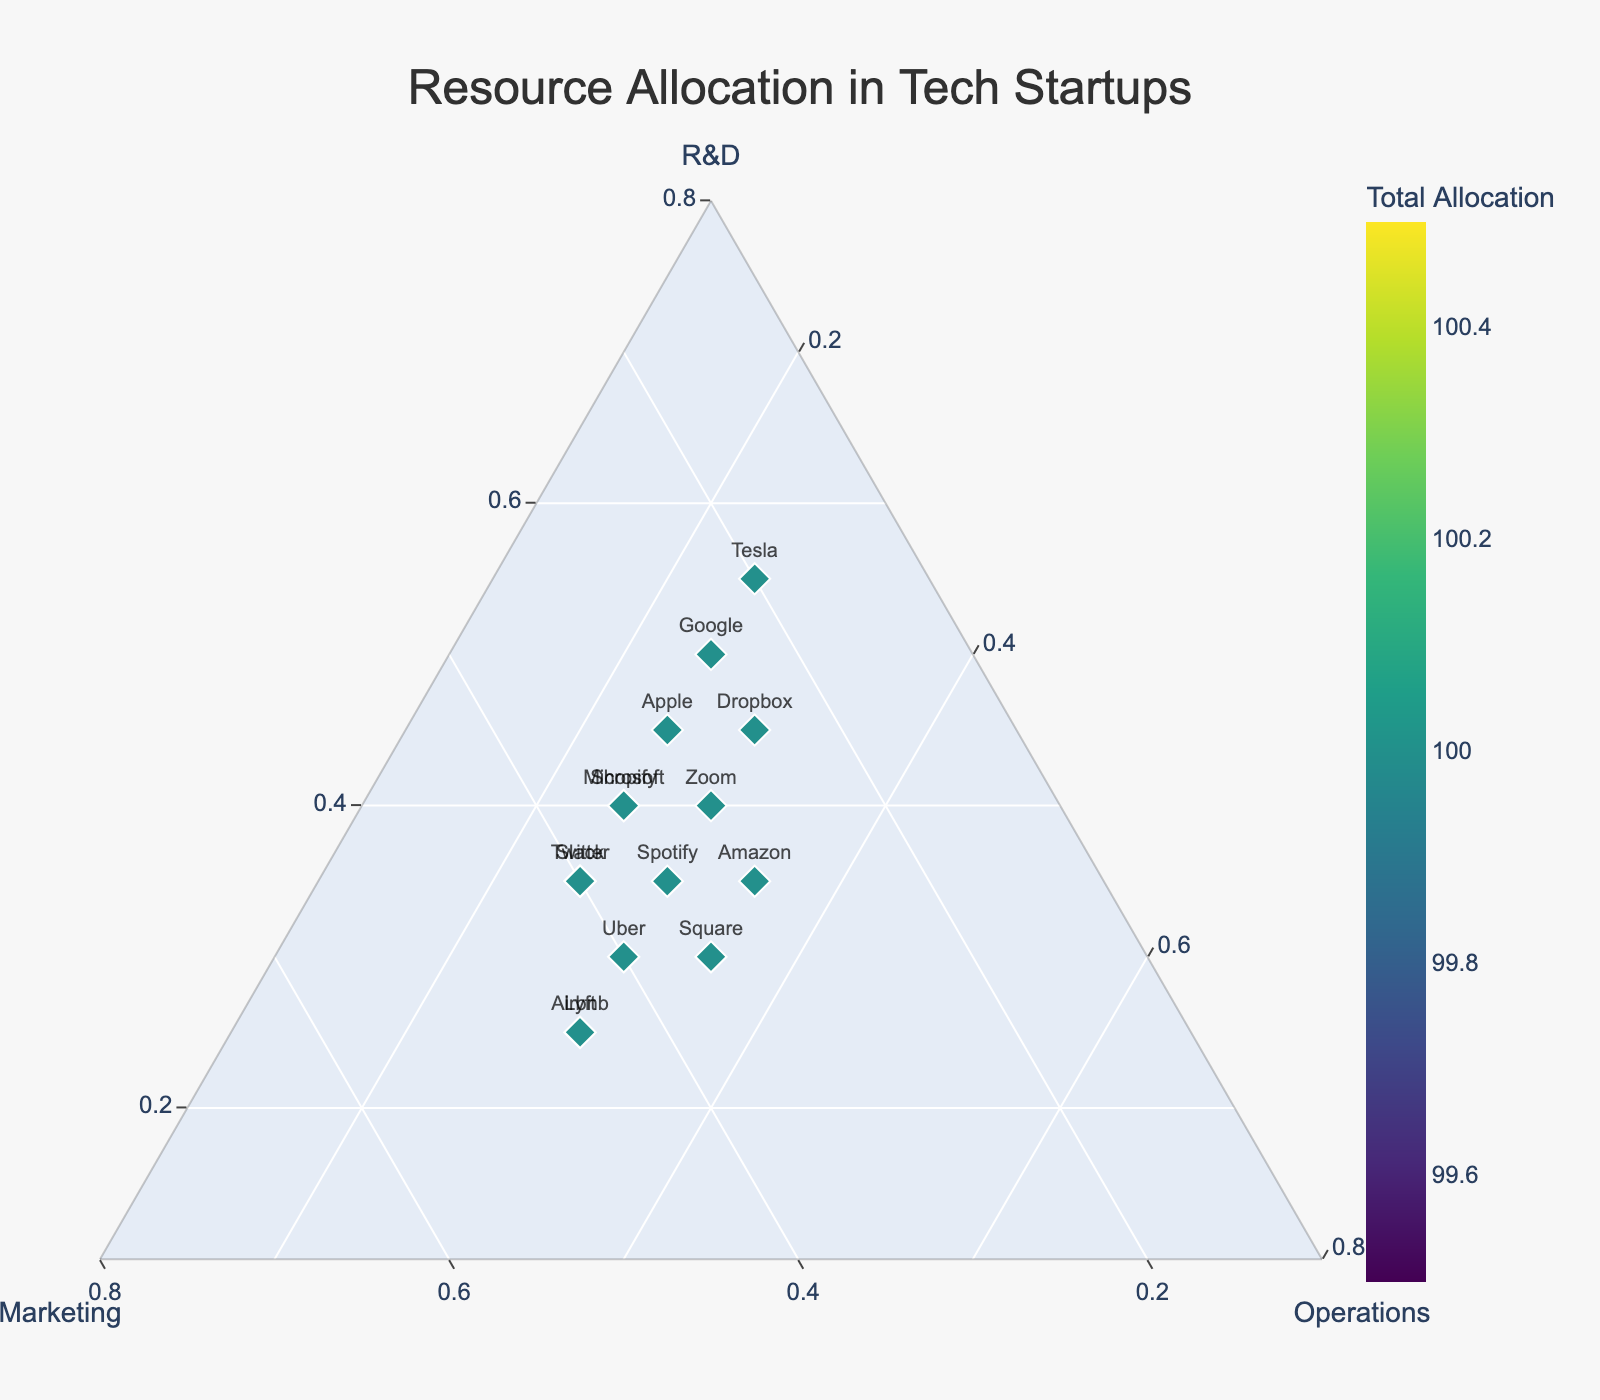What is the title of the figure? The title is prominent at the top center of the figure. It provides an overview of what the plot represents.
Answer: Resource Allocation in Tech Startups Which company has the highest allocation to R&D? By observing the ternary plot, look for the point closest to the R&D axis. Tesla, with 55%, is the highest.
Answer: Tesla Which axis represents Marketing? The axis titles are clearly marked. The b-axis, labeled 'Marketing', represents it.
Answer: b-axis How many companies allocate between 40% and 45% to Marketing? By examining the points around the Marketing axis and counting those within the range, we find that there are three: Airbnb, Lyft, and Slack.
Answer: 3 Which companies have an equal distribution of resources across all categories? Find points close to the center of the ternary plot where R&D, Marketing, and Operations are approximately equal. No company has a perfect equal distribution in this dataset.
Answer: None What is the total resource allocation for Google and Amazon combined? Sum the total allocations for each: Google (50 + 25 + 25 = 100) and Amazon (35 + 30 + 35 = 100), so the combined total is 100 + 100 = 200.
Answer: 200 Which company has the most balanced allocation between Marketing and Operations? Look at points that are equidistant from the Marketing and Operations axes. Amazon with 30% in Marketing and 35% in Operations is the most balanced among them.
Answer: Amazon Compare Apple and Microsoft in terms of R&D allocation. Who spends more? Check the R&D values next to the data points for Apple (45%) and Microsoft (40%). Apple allocates more to R&D.
Answer: Apple What color represents the highest total allocation in the plot's color scale? The color scale is indicated by the 'Total Allocation' color bar. The highest total allocation corresponds to the darkest color on the Viridis color scale.
Answer: Darkest color What percentage of resources does Uber allocate to Operations? By looking at the location of Uber on the plot, we see it lies close to 30% on the Operations axis.
Answer: 30% 